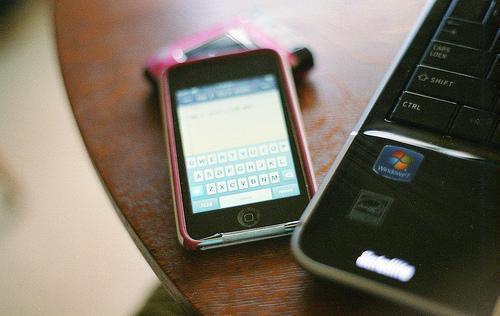How many phones are there?
Give a very brief answer. 2. 